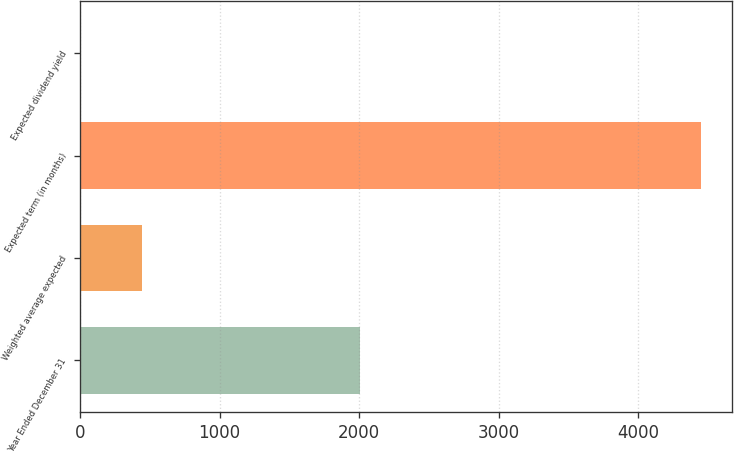Convert chart to OTSL. <chart><loc_0><loc_0><loc_500><loc_500><bar_chart><fcel>Year Ended December 31<fcel>Weighted average expected<fcel>Expected term (in months)<fcel>Expected dividend yield<nl><fcel>2008<fcel>446.35<fcel>4450<fcel>1.5<nl></chart> 